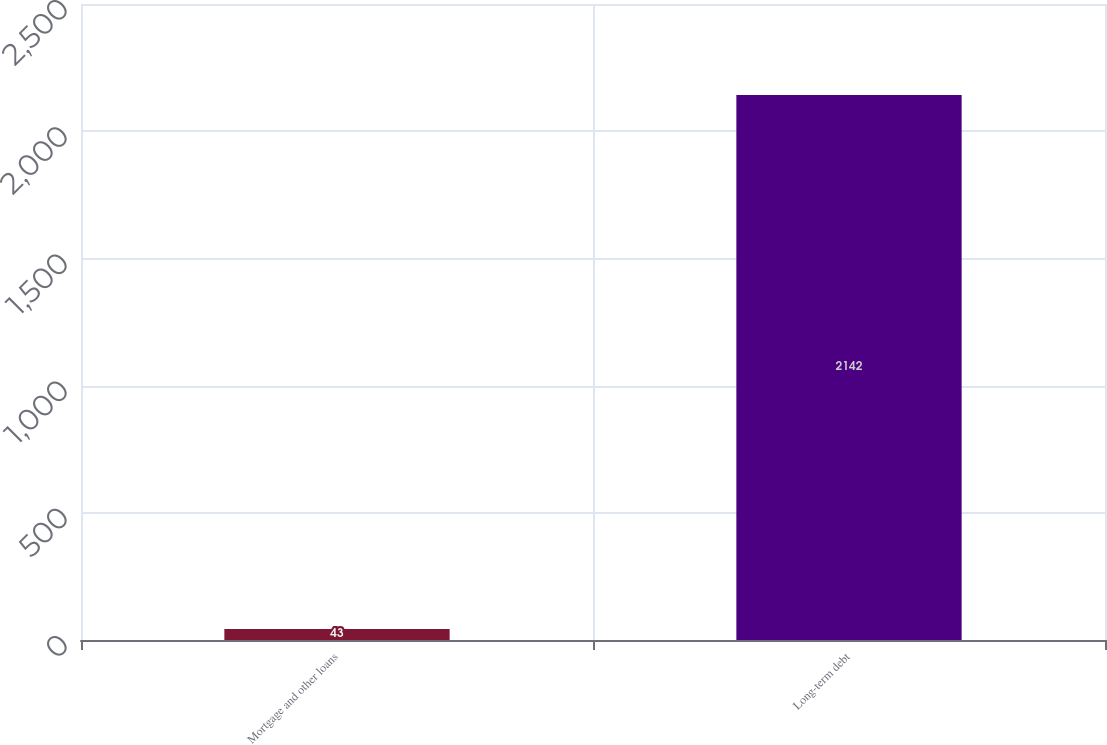Convert chart. <chart><loc_0><loc_0><loc_500><loc_500><bar_chart><fcel>Mortgage and other loans<fcel>Long-term debt<nl><fcel>43<fcel>2142<nl></chart> 